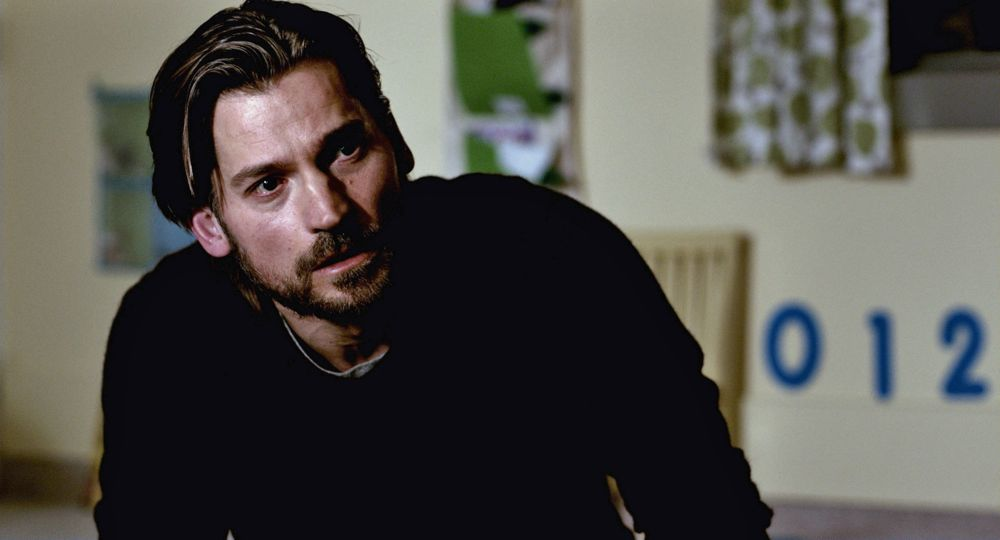What might the numbers '012' on the whiteboard represent? The '012' visible on the whiteboard behind the man might represent a multitude of things depending on the context, such as a code, part of a larger sequence, a date, or possibly a reference number in a professional or educational setting. It could be linked to a specific task he is addressing or tracking. 